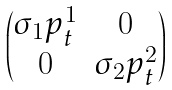<formula> <loc_0><loc_0><loc_500><loc_500>\begin{pmatrix} \sigma _ { 1 } p _ { t } ^ { 1 } & 0 \\ 0 & \sigma _ { 2 } p _ { t } ^ { 2 } \end{pmatrix}</formula> 